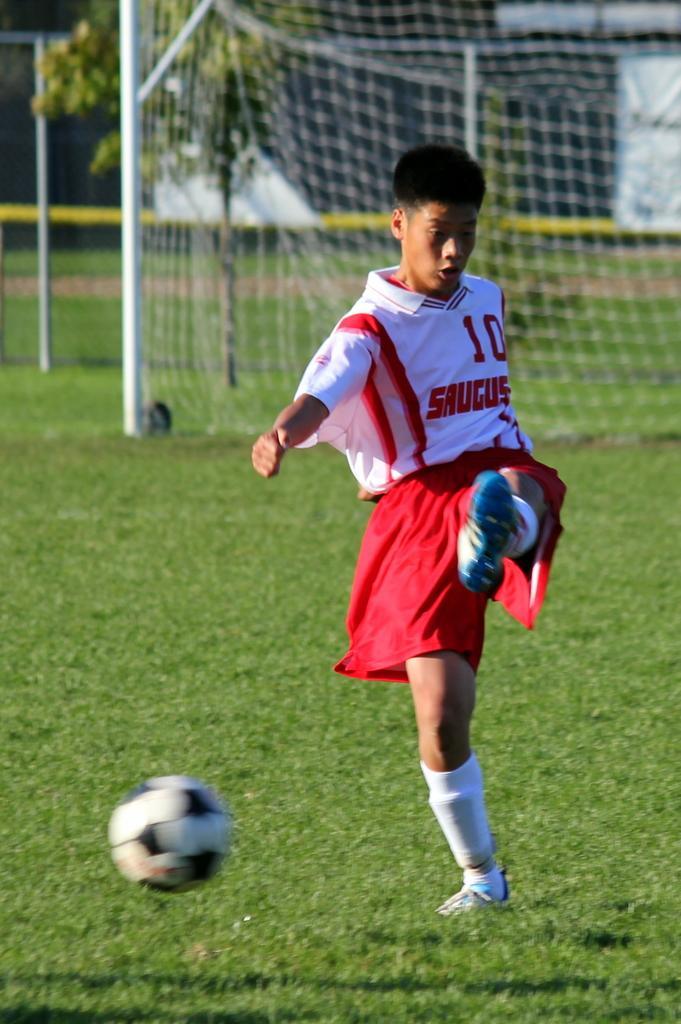In one or two sentences, can you explain what this image depicts? In this image we can see a person wearing white and red color dress playing football there is a ball in the air and in the background of the image there is net and some rods. 